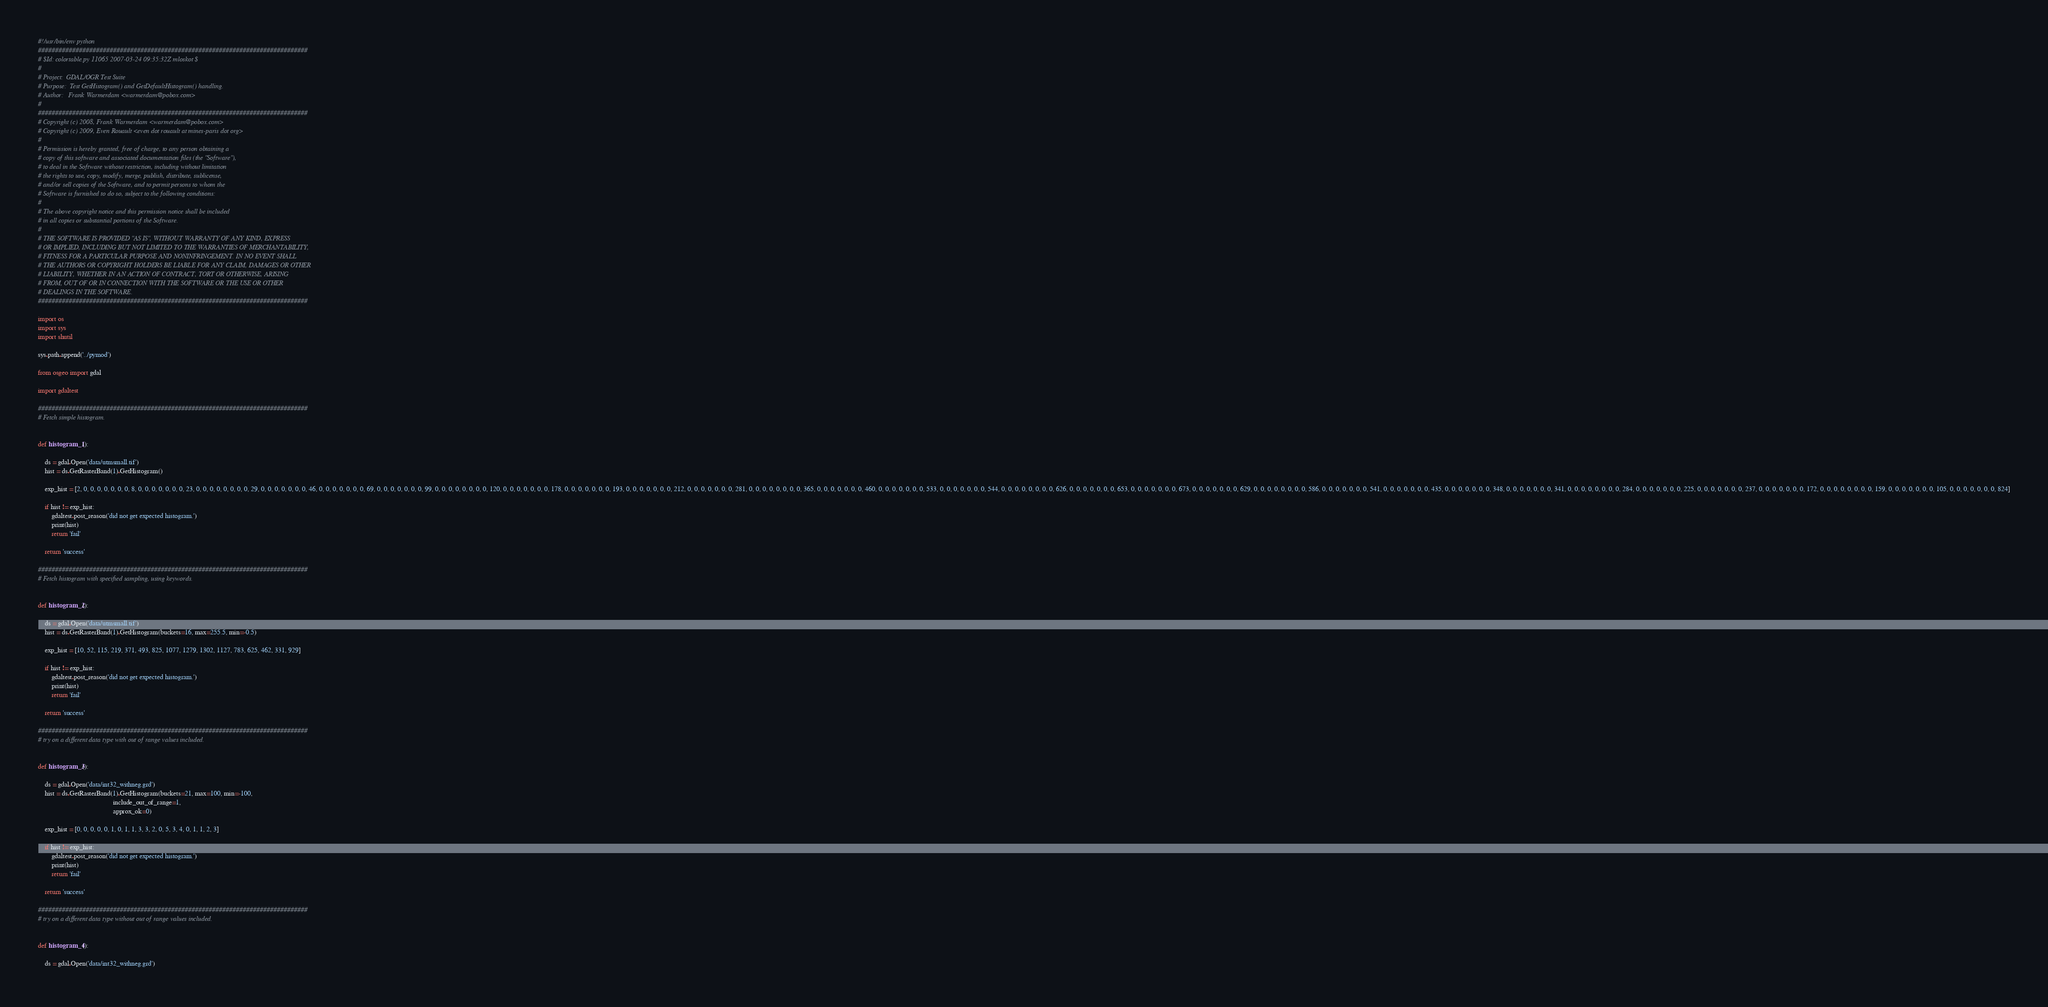<code> <loc_0><loc_0><loc_500><loc_500><_Python_>#!/usr/bin/env python
###############################################################################
# $Id: colortable.py 11065 2007-03-24 09:35:32Z mloskot $
#
# Project:  GDAL/OGR Test Suite
# Purpose:  Test GetHistogram() and GetDefaultHistogram() handling.
# Author:   Frank Warmerdam <warmerdam@pobox.com>
#
###############################################################################
# Copyright (c) 2008, Frank Warmerdam <warmerdam@pobox.com>
# Copyright (c) 2009, Even Rouault <even dot rouault at mines-paris dot org>
#
# Permission is hereby granted, free of charge, to any person obtaining a
# copy of this software and associated documentation files (the "Software"),
# to deal in the Software without restriction, including without limitation
# the rights to use, copy, modify, merge, publish, distribute, sublicense,
# and/or sell copies of the Software, and to permit persons to whom the
# Software is furnished to do so, subject to the following conditions:
#
# The above copyright notice and this permission notice shall be included
# in all copies or substantial portions of the Software.
#
# THE SOFTWARE IS PROVIDED "AS IS", WITHOUT WARRANTY OF ANY KIND, EXPRESS
# OR IMPLIED, INCLUDING BUT NOT LIMITED TO THE WARRANTIES OF MERCHANTABILITY,
# FITNESS FOR A PARTICULAR PURPOSE AND NONINFRINGEMENT. IN NO EVENT SHALL
# THE AUTHORS OR COPYRIGHT HOLDERS BE LIABLE FOR ANY CLAIM, DAMAGES OR OTHER
# LIABILITY, WHETHER IN AN ACTION OF CONTRACT, TORT OR OTHERWISE, ARISING
# FROM, OUT OF OR IN CONNECTION WITH THE SOFTWARE OR THE USE OR OTHER
# DEALINGS IN THE SOFTWARE.
###############################################################################

import os
import sys
import shutil

sys.path.append('../pymod')

from osgeo import gdal

import gdaltest

###############################################################################
# Fetch simple histogram.


def histogram_1():

    ds = gdal.Open('data/utmsmall.tif')
    hist = ds.GetRasterBand(1).GetHistogram()

    exp_hist = [2, 0, 0, 0, 0, 0, 0, 0, 8, 0, 0, 0, 0, 0, 0, 0, 23, 0, 0, 0, 0, 0, 0, 0, 0, 29, 0, 0, 0, 0, 0, 0, 0, 46, 0, 0, 0, 0, 0, 0, 0, 69, 0, 0, 0, 0, 0, 0, 0, 99, 0, 0, 0, 0, 0, 0, 0, 0, 120, 0, 0, 0, 0, 0, 0, 0, 178, 0, 0, 0, 0, 0, 0, 0, 193, 0, 0, 0, 0, 0, 0, 0, 212, 0, 0, 0, 0, 0, 0, 0, 281, 0, 0, 0, 0, 0, 0, 0, 0, 365, 0, 0, 0, 0, 0, 0, 0, 460, 0, 0, 0, 0, 0, 0, 0, 533, 0, 0, 0, 0, 0, 0, 0, 544, 0, 0, 0, 0, 0, 0, 0, 0, 626, 0, 0, 0, 0, 0, 0, 0, 653, 0, 0, 0, 0, 0, 0, 0, 673, 0, 0, 0, 0, 0, 0, 0, 629, 0, 0, 0, 0, 0, 0, 0, 0, 586, 0, 0, 0, 0, 0, 0, 0, 541, 0, 0, 0, 0, 0, 0, 0, 435, 0, 0, 0, 0, 0, 0, 0, 348, 0, 0, 0, 0, 0, 0, 0, 341, 0, 0, 0, 0, 0, 0, 0, 0, 284, 0, 0, 0, 0, 0, 0, 0, 225, 0, 0, 0, 0, 0, 0, 0, 237, 0, 0, 0, 0, 0, 0, 0, 172, 0, 0, 0, 0, 0, 0, 0, 0, 159, 0, 0, 0, 0, 0, 0, 0, 105, 0, 0, 0, 0, 0, 0, 0, 824]

    if hist != exp_hist:
        gdaltest.post_reason('did not get expected histogram.')
        print(hist)
        return 'fail'

    return 'success'

###############################################################################
# Fetch histogram with specified sampling, using keywords.


def histogram_2():

    ds = gdal.Open('data/utmsmall.tif')
    hist = ds.GetRasterBand(1).GetHistogram(buckets=16, max=255.5, min=-0.5)

    exp_hist = [10, 52, 115, 219, 371, 493, 825, 1077, 1279, 1302, 1127, 783, 625, 462, 331, 929]

    if hist != exp_hist:
        gdaltest.post_reason('did not get expected histogram.')
        print(hist)
        return 'fail'

    return 'success'

###############################################################################
# try on a different data type with out of range values included.


def histogram_3():

    ds = gdal.Open('data/int32_withneg.grd')
    hist = ds.GetRasterBand(1).GetHistogram(buckets=21, max=100, min=-100,
                                            include_out_of_range=1,
                                            approx_ok=0)

    exp_hist = [0, 0, 0, 0, 0, 1, 0, 1, 1, 3, 3, 2, 0, 5, 3, 4, 0, 1, 1, 2, 3]

    if hist != exp_hist:
        gdaltest.post_reason('did not get expected histogram.')
        print(hist)
        return 'fail'

    return 'success'

###############################################################################
# try on a different data type without out of range values included.


def histogram_4():

    ds = gdal.Open('data/int32_withneg.grd')</code> 